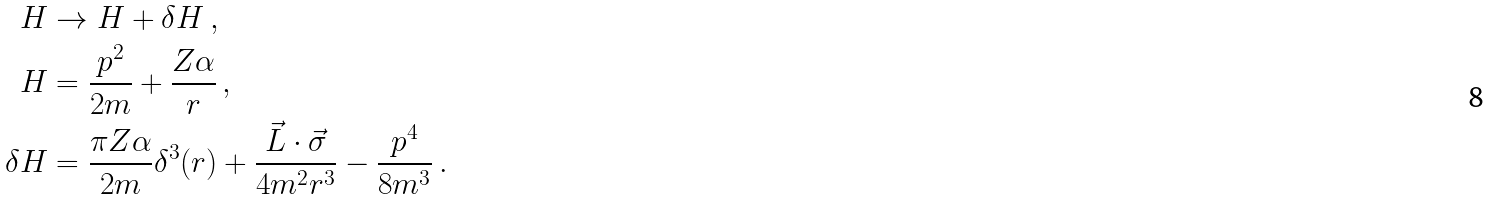<formula> <loc_0><loc_0><loc_500><loc_500>H & \rightarrow H + \delta H \, , \\ H & = \frac { p ^ { 2 } } { 2 m } + \frac { Z \alpha } { r } \, , \\ \delta H & = \frac { \pi Z \alpha } { 2 m } \delta ^ { 3 } ( r ) + \frac { \vec { L } \cdot \vec { \sigma } } { 4 m ^ { 2 } r ^ { 3 } } - \frac { p ^ { 4 } } { 8 m ^ { 3 } } \, .</formula> 